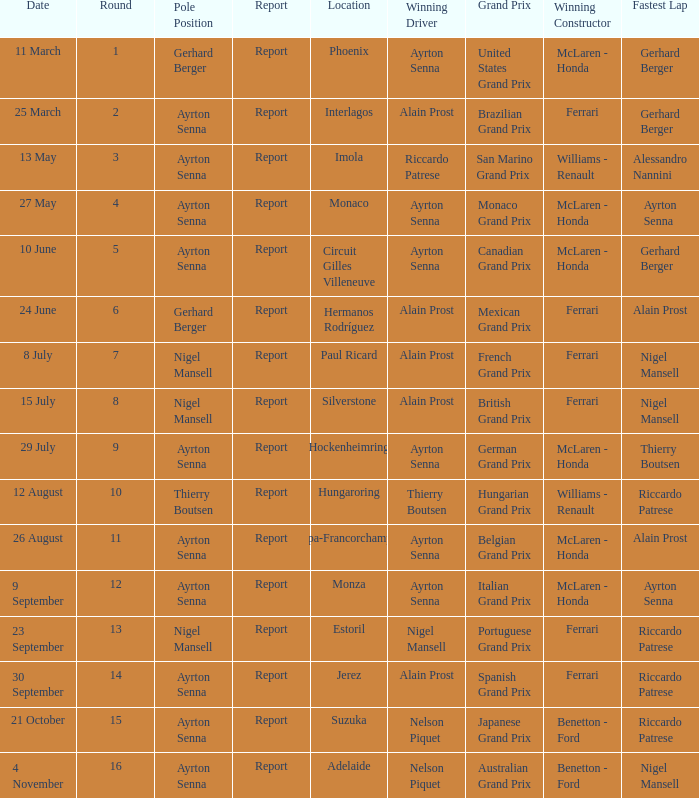Write the full table. {'header': ['Date', 'Round', 'Pole Position', 'Report', 'Location', 'Winning Driver', 'Grand Prix', 'Winning Constructor', 'Fastest Lap'], 'rows': [['11 March', '1', 'Gerhard Berger', 'Report', 'Phoenix', 'Ayrton Senna', 'United States Grand Prix', 'McLaren - Honda', 'Gerhard Berger'], ['25 March', '2', 'Ayrton Senna', 'Report', 'Interlagos', 'Alain Prost', 'Brazilian Grand Prix', 'Ferrari', 'Gerhard Berger'], ['13 May', '3', 'Ayrton Senna', 'Report', 'Imola', 'Riccardo Patrese', 'San Marino Grand Prix', 'Williams - Renault', 'Alessandro Nannini'], ['27 May', '4', 'Ayrton Senna', 'Report', 'Monaco', 'Ayrton Senna', 'Monaco Grand Prix', 'McLaren - Honda', 'Ayrton Senna'], ['10 June', '5', 'Ayrton Senna', 'Report', 'Circuit Gilles Villeneuve', 'Ayrton Senna', 'Canadian Grand Prix', 'McLaren - Honda', 'Gerhard Berger'], ['24 June', '6', 'Gerhard Berger', 'Report', 'Hermanos Rodríguez', 'Alain Prost', 'Mexican Grand Prix', 'Ferrari', 'Alain Prost'], ['8 July', '7', 'Nigel Mansell', 'Report', 'Paul Ricard', 'Alain Prost', 'French Grand Prix', 'Ferrari', 'Nigel Mansell'], ['15 July', '8', 'Nigel Mansell', 'Report', 'Silverstone', 'Alain Prost', 'British Grand Prix', 'Ferrari', 'Nigel Mansell'], ['29 July', '9', 'Ayrton Senna', 'Report', 'Hockenheimring', 'Ayrton Senna', 'German Grand Prix', 'McLaren - Honda', 'Thierry Boutsen'], ['12 August', '10', 'Thierry Boutsen', 'Report', 'Hungaroring', 'Thierry Boutsen', 'Hungarian Grand Prix', 'Williams - Renault', 'Riccardo Patrese'], ['26 August', '11', 'Ayrton Senna', 'Report', 'Spa-Francorchamps', 'Ayrton Senna', 'Belgian Grand Prix', 'McLaren - Honda', 'Alain Prost'], ['9 September', '12', 'Ayrton Senna', 'Report', 'Monza', 'Ayrton Senna', 'Italian Grand Prix', 'McLaren - Honda', 'Ayrton Senna'], ['23 September', '13', 'Nigel Mansell', 'Report', 'Estoril', 'Nigel Mansell', 'Portuguese Grand Prix', 'Ferrari', 'Riccardo Patrese'], ['30 September', '14', 'Ayrton Senna', 'Report', 'Jerez', 'Alain Prost', 'Spanish Grand Prix', 'Ferrari', 'Riccardo Patrese'], ['21 October', '15', 'Ayrton Senna', 'Report', 'Suzuka', 'Nelson Piquet', 'Japanese Grand Prix', 'Benetton - Ford', 'Riccardo Patrese'], ['4 November', '16', 'Ayrton Senna', 'Report', 'Adelaide', 'Nelson Piquet', 'Australian Grand Prix', 'Benetton - Ford', 'Nigel Mansell']]} What was the constructor when riccardo patrese was the winning driver? Williams - Renault. 